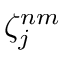<formula> <loc_0><loc_0><loc_500><loc_500>\zeta _ { j } ^ { n m }</formula> 